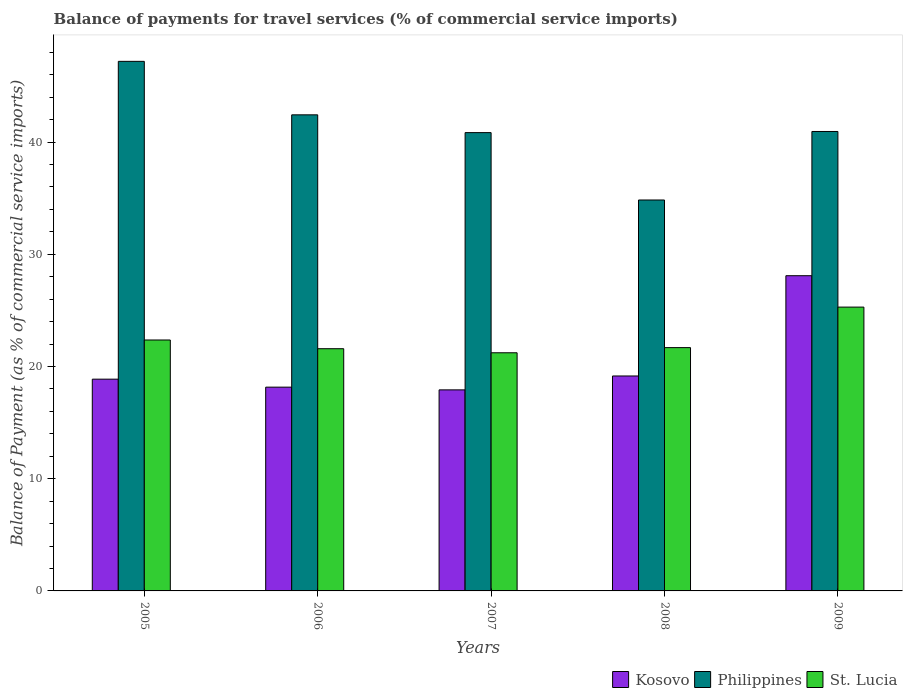How many different coloured bars are there?
Offer a very short reply. 3. How many groups of bars are there?
Make the answer very short. 5. Are the number of bars per tick equal to the number of legend labels?
Your answer should be compact. Yes. Are the number of bars on each tick of the X-axis equal?
Offer a terse response. Yes. How many bars are there on the 4th tick from the left?
Provide a succinct answer. 3. How many bars are there on the 3rd tick from the right?
Make the answer very short. 3. What is the label of the 3rd group of bars from the left?
Offer a very short reply. 2007. What is the balance of payments for travel services in Philippines in 2005?
Your answer should be very brief. 47.2. Across all years, what is the maximum balance of payments for travel services in Philippines?
Your answer should be compact. 47.2. Across all years, what is the minimum balance of payments for travel services in Kosovo?
Offer a very short reply. 17.92. In which year was the balance of payments for travel services in St. Lucia minimum?
Keep it short and to the point. 2007. What is the total balance of payments for travel services in St. Lucia in the graph?
Provide a succinct answer. 112.15. What is the difference between the balance of payments for travel services in Kosovo in 2006 and that in 2009?
Provide a short and direct response. -9.93. What is the difference between the balance of payments for travel services in Kosovo in 2008 and the balance of payments for travel services in St. Lucia in 2005?
Offer a very short reply. -3.21. What is the average balance of payments for travel services in St. Lucia per year?
Your answer should be very brief. 22.43. In the year 2009, what is the difference between the balance of payments for travel services in Kosovo and balance of payments for travel services in St. Lucia?
Your response must be concise. 2.8. In how many years, is the balance of payments for travel services in St. Lucia greater than 20 %?
Give a very brief answer. 5. What is the ratio of the balance of payments for travel services in Philippines in 2006 to that in 2007?
Offer a terse response. 1.04. Is the balance of payments for travel services in Kosovo in 2005 less than that in 2009?
Give a very brief answer. Yes. Is the difference between the balance of payments for travel services in Kosovo in 2006 and 2007 greater than the difference between the balance of payments for travel services in St. Lucia in 2006 and 2007?
Offer a terse response. No. What is the difference between the highest and the second highest balance of payments for travel services in Philippines?
Offer a terse response. 4.77. What is the difference between the highest and the lowest balance of payments for travel services in Kosovo?
Make the answer very short. 10.17. What does the 1st bar from the right in 2005 represents?
Provide a short and direct response. St. Lucia. Is it the case that in every year, the sum of the balance of payments for travel services in Philippines and balance of payments for travel services in Kosovo is greater than the balance of payments for travel services in St. Lucia?
Provide a succinct answer. Yes. What is the difference between two consecutive major ticks on the Y-axis?
Offer a terse response. 10. Are the values on the major ticks of Y-axis written in scientific E-notation?
Provide a short and direct response. No. Does the graph contain any zero values?
Your answer should be very brief. No. What is the title of the graph?
Provide a succinct answer. Balance of payments for travel services (% of commercial service imports). What is the label or title of the Y-axis?
Your answer should be compact. Balance of Payment (as % of commercial service imports). What is the Balance of Payment (as % of commercial service imports) in Kosovo in 2005?
Your response must be concise. 18.87. What is the Balance of Payment (as % of commercial service imports) of Philippines in 2005?
Provide a succinct answer. 47.2. What is the Balance of Payment (as % of commercial service imports) in St. Lucia in 2005?
Provide a succinct answer. 22.36. What is the Balance of Payment (as % of commercial service imports) of Kosovo in 2006?
Your answer should be very brief. 18.16. What is the Balance of Payment (as % of commercial service imports) in Philippines in 2006?
Give a very brief answer. 42.43. What is the Balance of Payment (as % of commercial service imports) of St. Lucia in 2006?
Make the answer very short. 21.59. What is the Balance of Payment (as % of commercial service imports) of Kosovo in 2007?
Offer a very short reply. 17.92. What is the Balance of Payment (as % of commercial service imports) in Philippines in 2007?
Provide a short and direct response. 40.84. What is the Balance of Payment (as % of commercial service imports) of St. Lucia in 2007?
Your answer should be very brief. 21.22. What is the Balance of Payment (as % of commercial service imports) in Kosovo in 2008?
Provide a succinct answer. 19.16. What is the Balance of Payment (as % of commercial service imports) in Philippines in 2008?
Your response must be concise. 34.84. What is the Balance of Payment (as % of commercial service imports) of St. Lucia in 2008?
Provide a short and direct response. 21.68. What is the Balance of Payment (as % of commercial service imports) in Kosovo in 2009?
Give a very brief answer. 28.09. What is the Balance of Payment (as % of commercial service imports) of Philippines in 2009?
Offer a terse response. 40.95. What is the Balance of Payment (as % of commercial service imports) in St. Lucia in 2009?
Keep it short and to the point. 25.29. Across all years, what is the maximum Balance of Payment (as % of commercial service imports) of Kosovo?
Your response must be concise. 28.09. Across all years, what is the maximum Balance of Payment (as % of commercial service imports) of Philippines?
Provide a succinct answer. 47.2. Across all years, what is the maximum Balance of Payment (as % of commercial service imports) in St. Lucia?
Offer a very short reply. 25.29. Across all years, what is the minimum Balance of Payment (as % of commercial service imports) in Kosovo?
Offer a very short reply. 17.92. Across all years, what is the minimum Balance of Payment (as % of commercial service imports) in Philippines?
Your answer should be compact. 34.84. Across all years, what is the minimum Balance of Payment (as % of commercial service imports) in St. Lucia?
Make the answer very short. 21.22. What is the total Balance of Payment (as % of commercial service imports) of Kosovo in the graph?
Your answer should be compact. 102.2. What is the total Balance of Payment (as % of commercial service imports) of Philippines in the graph?
Ensure brevity in your answer.  206.26. What is the total Balance of Payment (as % of commercial service imports) in St. Lucia in the graph?
Offer a terse response. 112.15. What is the difference between the Balance of Payment (as % of commercial service imports) in Kosovo in 2005 and that in 2006?
Ensure brevity in your answer.  0.71. What is the difference between the Balance of Payment (as % of commercial service imports) of Philippines in 2005 and that in 2006?
Make the answer very short. 4.77. What is the difference between the Balance of Payment (as % of commercial service imports) in St. Lucia in 2005 and that in 2006?
Your answer should be compact. 0.78. What is the difference between the Balance of Payment (as % of commercial service imports) of Kosovo in 2005 and that in 2007?
Offer a terse response. 0.95. What is the difference between the Balance of Payment (as % of commercial service imports) in Philippines in 2005 and that in 2007?
Your answer should be compact. 6.35. What is the difference between the Balance of Payment (as % of commercial service imports) in St. Lucia in 2005 and that in 2007?
Provide a short and direct response. 1.14. What is the difference between the Balance of Payment (as % of commercial service imports) of Kosovo in 2005 and that in 2008?
Your answer should be very brief. -0.28. What is the difference between the Balance of Payment (as % of commercial service imports) in Philippines in 2005 and that in 2008?
Provide a succinct answer. 12.36. What is the difference between the Balance of Payment (as % of commercial service imports) in St. Lucia in 2005 and that in 2008?
Ensure brevity in your answer.  0.68. What is the difference between the Balance of Payment (as % of commercial service imports) in Kosovo in 2005 and that in 2009?
Make the answer very short. -9.22. What is the difference between the Balance of Payment (as % of commercial service imports) in Philippines in 2005 and that in 2009?
Your answer should be compact. 6.25. What is the difference between the Balance of Payment (as % of commercial service imports) in St. Lucia in 2005 and that in 2009?
Your response must be concise. -2.93. What is the difference between the Balance of Payment (as % of commercial service imports) in Kosovo in 2006 and that in 2007?
Make the answer very short. 0.24. What is the difference between the Balance of Payment (as % of commercial service imports) in Philippines in 2006 and that in 2007?
Give a very brief answer. 1.58. What is the difference between the Balance of Payment (as % of commercial service imports) in St. Lucia in 2006 and that in 2007?
Your answer should be very brief. 0.36. What is the difference between the Balance of Payment (as % of commercial service imports) of Kosovo in 2006 and that in 2008?
Give a very brief answer. -0.99. What is the difference between the Balance of Payment (as % of commercial service imports) of Philippines in 2006 and that in 2008?
Offer a terse response. 7.59. What is the difference between the Balance of Payment (as % of commercial service imports) in St. Lucia in 2006 and that in 2008?
Give a very brief answer. -0.1. What is the difference between the Balance of Payment (as % of commercial service imports) in Kosovo in 2006 and that in 2009?
Offer a terse response. -9.93. What is the difference between the Balance of Payment (as % of commercial service imports) in Philippines in 2006 and that in 2009?
Your response must be concise. 1.48. What is the difference between the Balance of Payment (as % of commercial service imports) of St. Lucia in 2006 and that in 2009?
Your answer should be compact. -3.71. What is the difference between the Balance of Payment (as % of commercial service imports) of Kosovo in 2007 and that in 2008?
Offer a terse response. -1.24. What is the difference between the Balance of Payment (as % of commercial service imports) in Philippines in 2007 and that in 2008?
Your response must be concise. 6. What is the difference between the Balance of Payment (as % of commercial service imports) of St. Lucia in 2007 and that in 2008?
Make the answer very short. -0.46. What is the difference between the Balance of Payment (as % of commercial service imports) in Kosovo in 2007 and that in 2009?
Keep it short and to the point. -10.17. What is the difference between the Balance of Payment (as % of commercial service imports) of Philippines in 2007 and that in 2009?
Provide a short and direct response. -0.1. What is the difference between the Balance of Payment (as % of commercial service imports) in St. Lucia in 2007 and that in 2009?
Keep it short and to the point. -4.07. What is the difference between the Balance of Payment (as % of commercial service imports) of Kosovo in 2008 and that in 2009?
Provide a short and direct response. -8.94. What is the difference between the Balance of Payment (as % of commercial service imports) of Philippines in 2008 and that in 2009?
Offer a terse response. -6.11. What is the difference between the Balance of Payment (as % of commercial service imports) of St. Lucia in 2008 and that in 2009?
Make the answer very short. -3.61. What is the difference between the Balance of Payment (as % of commercial service imports) in Kosovo in 2005 and the Balance of Payment (as % of commercial service imports) in Philippines in 2006?
Ensure brevity in your answer.  -23.56. What is the difference between the Balance of Payment (as % of commercial service imports) in Kosovo in 2005 and the Balance of Payment (as % of commercial service imports) in St. Lucia in 2006?
Make the answer very short. -2.71. What is the difference between the Balance of Payment (as % of commercial service imports) of Philippines in 2005 and the Balance of Payment (as % of commercial service imports) of St. Lucia in 2006?
Your response must be concise. 25.61. What is the difference between the Balance of Payment (as % of commercial service imports) in Kosovo in 2005 and the Balance of Payment (as % of commercial service imports) in Philippines in 2007?
Offer a very short reply. -21.97. What is the difference between the Balance of Payment (as % of commercial service imports) of Kosovo in 2005 and the Balance of Payment (as % of commercial service imports) of St. Lucia in 2007?
Your answer should be compact. -2.35. What is the difference between the Balance of Payment (as % of commercial service imports) of Philippines in 2005 and the Balance of Payment (as % of commercial service imports) of St. Lucia in 2007?
Give a very brief answer. 25.97. What is the difference between the Balance of Payment (as % of commercial service imports) in Kosovo in 2005 and the Balance of Payment (as % of commercial service imports) in Philippines in 2008?
Give a very brief answer. -15.97. What is the difference between the Balance of Payment (as % of commercial service imports) in Kosovo in 2005 and the Balance of Payment (as % of commercial service imports) in St. Lucia in 2008?
Your answer should be very brief. -2.81. What is the difference between the Balance of Payment (as % of commercial service imports) of Philippines in 2005 and the Balance of Payment (as % of commercial service imports) of St. Lucia in 2008?
Ensure brevity in your answer.  25.51. What is the difference between the Balance of Payment (as % of commercial service imports) of Kosovo in 2005 and the Balance of Payment (as % of commercial service imports) of Philippines in 2009?
Offer a terse response. -22.07. What is the difference between the Balance of Payment (as % of commercial service imports) in Kosovo in 2005 and the Balance of Payment (as % of commercial service imports) in St. Lucia in 2009?
Give a very brief answer. -6.42. What is the difference between the Balance of Payment (as % of commercial service imports) in Philippines in 2005 and the Balance of Payment (as % of commercial service imports) in St. Lucia in 2009?
Offer a terse response. 21.9. What is the difference between the Balance of Payment (as % of commercial service imports) of Kosovo in 2006 and the Balance of Payment (as % of commercial service imports) of Philippines in 2007?
Offer a terse response. -22.68. What is the difference between the Balance of Payment (as % of commercial service imports) in Kosovo in 2006 and the Balance of Payment (as % of commercial service imports) in St. Lucia in 2007?
Make the answer very short. -3.06. What is the difference between the Balance of Payment (as % of commercial service imports) of Philippines in 2006 and the Balance of Payment (as % of commercial service imports) of St. Lucia in 2007?
Give a very brief answer. 21.21. What is the difference between the Balance of Payment (as % of commercial service imports) in Kosovo in 2006 and the Balance of Payment (as % of commercial service imports) in Philippines in 2008?
Your answer should be compact. -16.68. What is the difference between the Balance of Payment (as % of commercial service imports) in Kosovo in 2006 and the Balance of Payment (as % of commercial service imports) in St. Lucia in 2008?
Give a very brief answer. -3.52. What is the difference between the Balance of Payment (as % of commercial service imports) of Philippines in 2006 and the Balance of Payment (as % of commercial service imports) of St. Lucia in 2008?
Provide a short and direct response. 20.75. What is the difference between the Balance of Payment (as % of commercial service imports) of Kosovo in 2006 and the Balance of Payment (as % of commercial service imports) of Philippines in 2009?
Ensure brevity in your answer.  -22.79. What is the difference between the Balance of Payment (as % of commercial service imports) of Kosovo in 2006 and the Balance of Payment (as % of commercial service imports) of St. Lucia in 2009?
Keep it short and to the point. -7.13. What is the difference between the Balance of Payment (as % of commercial service imports) of Philippines in 2006 and the Balance of Payment (as % of commercial service imports) of St. Lucia in 2009?
Provide a short and direct response. 17.14. What is the difference between the Balance of Payment (as % of commercial service imports) in Kosovo in 2007 and the Balance of Payment (as % of commercial service imports) in Philippines in 2008?
Keep it short and to the point. -16.92. What is the difference between the Balance of Payment (as % of commercial service imports) of Kosovo in 2007 and the Balance of Payment (as % of commercial service imports) of St. Lucia in 2008?
Provide a short and direct response. -3.77. What is the difference between the Balance of Payment (as % of commercial service imports) in Philippines in 2007 and the Balance of Payment (as % of commercial service imports) in St. Lucia in 2008?
Provide a succinct answer. 19.16. What is the difference between the Balance of Payment (as % of commercial service imports) in Kosovo in 2007 and the Balance of Payment (as % of commercial service imports) in Philippines in 2009?
Your answer should be very brief. -23.03. What is the difference between the Balance of Payment (as % of commercial service imports) of Kosovo in 2007 and the Balance of Payment (as % of commercial service imports) of St. Lucia in 2009?
Offer a very short reply. -7.38. What is the difference between the Balance of Payment (as % of commercial service imports) of Philippines in 2007 and the Balance of Payment (as % of commercial service imports) of St. Lucia in 2009?
Provide a short and direct response. 15.55. What is the difference between the Balance of Payment (as % of commercial service imports) of Kosovo in 2008 and the Balance of Payment (as % of commercial service imports) of Philippines in 2009?
Offer a terse response. -21.79. What is the difference between the Balance of Payment (as % of commercial service imports) of Kosovo in 2008 and the Balance of Payment (as % of commercial service imports) of St. Lucia in 2009?
Keep it short and to the point. -6.14. What is the difference between the Balance of Payment (as % of commercial service imports) of Philippines in 2008 and the Balance of Payment (as % of commercial service imports) of St. Lucia in 2009?
Ensure brevity in your answer.  9.55. What is the average Balance of Payment (as % of commercial service imports) of Kosovo per year?
Your answer should be very brief. 20.44. What is the average Balance of Payment (as % of commercial service imports) of Philippines per year?
Your answer should be compact. 41.25. What is the average Balance of Payment (as % of commercial service imports) of St. Lucia per year?
Your answer should be compact. 22.43. In the year 2005, what is the difference between the Balance of Payment (as % of commercial service imports) in Kosovo and Balance of Payment (as % of commercial service imports) in Philippines?
Offer a terse response. -28.32. In the year 2005, what is the difference between the Balance of Payment (as % of commercial service imports) of Kosovo and Balance of Payment (as % of commercial service imports) of St. Lucia?
Keep it short and to the point. -3.49. In the year 2005, what is the difference between the Balance of Payment (as % of commercial service imports) of Philippines and Balance of Payment (as % of commercial service imports) of St. Lucia?
Provide a succinct answer. 24.83. In the year 2006, what is the difference between the Balance of Payment (as % of commercial service imports) in Kosovo and Balance of Payment (as % of commercial service imports) in Philippines?
Offer a very short reply. -24.27. In the year 2006, what is the difference between the Balance of Payment (as % of commercial service imports) in Kosovo and Balance of Payment (as % of commercial service imports) in St. Lucia?
Your answer should be very brief. -3.43. In the year 2006, what is the difference between the Balance of Payment (as % of commercial service imports) of Philippines and Balance of Payment (as % of commercial service imports) of St. Lucia?
Provide a succinct answer. 20.84. In the year 2007, what is the difference between the Balance of Payment (as % of commercial service imports) in Kosovo and Balance of Payment (as % of commercial service imports) in Philippines?
Give a very brief answer. -22.93. In the year 2007, what is the difference between the Balance of Payment (as % of commercial service imports) of Kosovo and Balance of Payment (as % of commercial service imports) of St. Lucia?
Provide a short and direct response. -3.31. In the year 2007, what is the difference between the Balance of Payment (as % of commercial service imports) in Philippines and Balance of Payment (as % of commercial service imports) in St. Lucia?
Provide a succinct answer. 19.62. In the year 2008, what is the difference between the Balance of Payment (as % of commercial service imports) of Kosovo and Balance of Payment (as % of commercial service imports) of Philippines?
Make the answer very short. -15.68. In the year 2008, what is the difference between the Balance of Payment (as % of commercial service imports) in Kosovo and Balance of Payment (as % of commercial service imports) in St. Lucia?
Your answer should be very brief. -2.53. In the year 2008, what is the difference between the Balance of Payment (as % of commercial service imports) of Philippines and Balance of Payment (as % of commercial service imports) of St. Lucia?
Give a very brief answer. 13.16. In the year 2009, what is the difference between the Balance of Payment (as % of commercial service imports) in Kosovo and Balance of Payment (as % of commercial service imports) in Philippines?
Your answer should be very brief. -12.85. In the year 2009, what is the difference between the Balance of Payment (as % of commercial service imports) in Kosovo and Balance of Payment (as % of commercial service imports) in St. Lucia?
Offer a terse response. 2.8. In the year 2009, what is the difference between the Balance of Payment (as % of commercial service imports) of Philippines and Balance of Payment (as % of commercial service imports) of St. Lucia?
Provide a succinct answer. 15.65. What is the ratio of the Balance of Payment (as % of commercial service imports) of Kosovo in 2005 to that in 2006?
Provide a succinct answer. 1.04. What is the ratio of the Balance of Payment (as % of commercial service imports) in Philippines in 2005 to that in 2006?
Provide a succinct answer. 1.11. What is the ratio of the Balance of Payment (as % of commercial service imports) in St. Lucia in 2005 to that in 2006?
Provide a succinct answer. 1.04. What is the ratio of the Balance of Payment (as % of commercial service imports) of Kosovo in 2005 to that in 2007?
Give a very brief answer. 1.05. What is the ratio of the Balance of Payment (as % of commercial service imports) of Philippines in 2005 to that in 2007?
Provide a succinct answer. 1.16. What is the ratio of the Balance of Payment (as % of commercial service imports) in St. Lucia in 2005 to that in 2007?
Keep it short and to the point. 1.05. What is the ratio of the Balance of Payment (as % of commercial service imports) of Kosovo in 2005 to that in 2008?
Your response must be concise. 0.99. What is the ratio of the Balance of Payment (as % of commercial service imports) in Philippines in 2005 to that in 2008?
Provide a short and direct response. 1.35. What is the ratio of the Balance of Payment (as % of commercial service imports) in St. Lucia in 2005 to that in 2008?
Make the answer very short. 1.03. What is the ratio of the Balance of Payment (as % of commercial service imports) of Kosovo in 2005 to that in 2009?
Keep it short and to the point. 0.67. What is the ratio of the Balance of Payment (as % of commercial service imports) of Philippines in 2005 to that in 2009?
Offer a terse response. 1.15. What is the ratio of the Balance of Payment (as % of commercial service imports) of St. Lucia in 2005 to that in 2009?
Give a very brief answer. 0.88. What is the ratio of the Balance of Payment (as % of commercial service imports) in Kosovo in 2006 to that in 2007?
Ensure brevity in your answer.  1.01. What is the ratio of the Balance of Payment (as % of commercial service imports) of Philippines in 2006 to that in 2007?
Ensure brevity in your answer.  1.04. What is the ratio of the Balance of Payment (as % of commercial service imports) in St. Lucia in 2006 to that in 2007?
Give a very brief answer. 1.02. What is the ratio of the Balance of Payment (as % of commercial service imports) in Kosovo in 2006 to that in 2008?
Provide a short and direct response. 0.95. What is the ratio of the Balance of Payment (as % of commercial service imports) of Philippines in 2006 to that in 2008?
Your response must be concise. 1.22. What is the ratio of the Balance of Payment (as % of commercial service imports) in Kosovo in 2006 to that in 2009?
Give a very brief answer. 0.65. What is the ratio of the Balance of Payment (as % of commercial service imports) in Philippines in 2006 to that in 2009?
Your answer should be compact. 1.04. What is the ratio of the Balance of Payment (as % of commercial service imports) in St. Lucia in 2006 to that in 2009?
Ensure brevity in your answer.  0.85. What is the ratio of the Balance of Payment (as % of commercial service imports) in Kosovo in 2007 to that in 2008?
Your answer should be compact. 0.94. What is the ratio of the Balance of Payment (as % of commercial service imports) of Philippines in 2007 to that in 2008?
Your response must be concise. 1.17. What is the ratio of the Balance of Payment (as % of commercial service imports) of St. Lucia in 2007 to that in 2008?
Make the answer very short. 0.98. What is the ratio of the Balance of Payment (as % of commercial service imports) of Kosovo in 2007 to that in 2009?
Your response must be concise. 0.64. What is the ratio of the Balance of Payment (as % of commercial service imports) of Philippines in 2007 to that in 2009?
Ensure brevity in your answer.  1. What is the ratio of the Balance of Payment (as % of commercial service imports) of St. Lucia in 2007 to that in 2009?
Offer a very short reply. 0.84. What is the ratio of the Balance of Payment (as % of commercial service imports) of Kosovo in 2008 to that in 2009?
Ensure brevity in your answer.  0.68. What is the ratio of the Balance of Payment (as % of commercial service imports) of Philippines in 2008 to that in 2009?
Your answer should be compact. 0.85. What is the ratio of the Balance of Payment (as % of commercial service imports) in St. Lucia in 2008 to that in 2009?
Your response must be concise. 0.86. What is the difference between the highest and the second highest Balance of Payment (as % of commercial service imports) in Kosovo?
Your answer should be compact. 8.94. What is the difference between the highest and the second highest Balance of Payment (as % of commercial service imports) of Philippines?
Provide a short and direct response. 4.77. What is the difference between the highest and the second highest Balance of Payment (as % of commercial service imports) of St. Lucia?
Keep it short and to the point. 2.93. What is the difference between the highest and the lowest Balance of Payment (as % of commercial service imports) in Kosovo?
Your response must be concise. 10.17. What is the difference between the highest and the lowest Balance of Payment (as % of commercial service imports) in Philippines?
Provide a succinct answer. 12.36. What is the difference between the highest and the lowest Balance of Payment (as % of commercial service imports) in St. Lucia?
Your response must be concise. 4.07. 